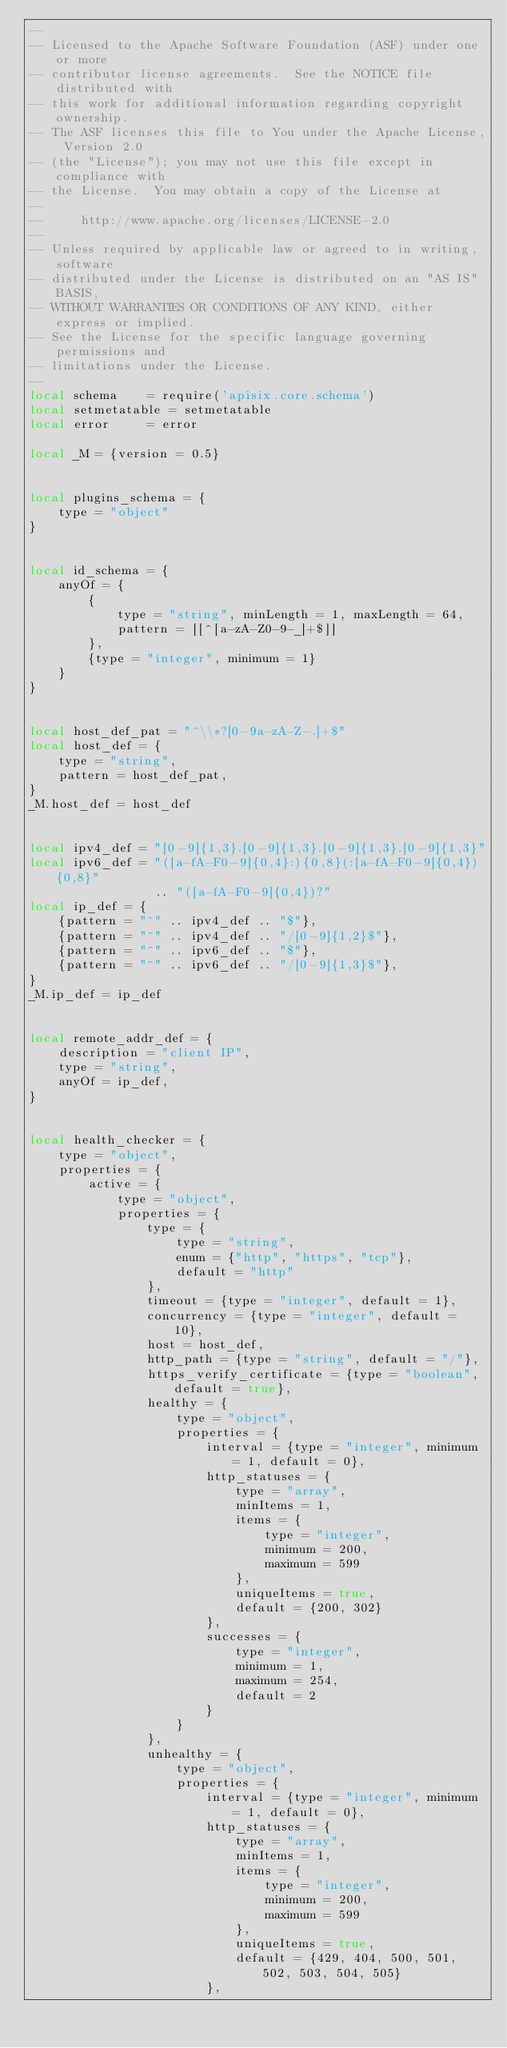<code> <loc_0><loc_0><loc_500><loc_500><_Lua_>--
-- Licensed to the Apache Software Foundation (ASF) under one or more
-- contributor license agreements.  See the NOTICE file distributed with
-- this work for additional information regarding copyright ownership.
-- The ASF licenses this file to You under the Apache License, Version 2.0
-- (the "License"); you may not use this file except in compliance with
-- the License.  You may obtain a copy of the License at
--
--     http://www.apache.org/licenses/LICENSE-2.0
--
-- Unless required by applicable law or agreed to in writing, software
-- distributed under the License is distributed on an "AS IS" BASIS,
-- WITHOUT WARRANTIES OR CONDITIONS OF ANY KIND, either express or implied.
-- See the License for the specific language governing permissions and
-- limitations under the License.
--
local schema    = require('apisix.core.schema')
local setmetatable = setmetatable
local error     = error

local _M = {version = 0.5}


local plugins_schema = {
    type = "object"
}


local id_schema = {
    anyOf = {
        {
            type = "string", minLength = 1, maxLength = 64,
            pattern = [[^[a-zA-Z0-9-_]+$]]
        },
        {type = "integer", minimum = 1}
    }
}


local host_def_pat = "^\\*?[0-9a-zA-Z-.]+$"
local host_def = {
    type = "string",
    pattern = host_def_pat,
}
_M.host_def = host_def


local ipv4_def = "[0-9]{1,3}.[0-9]{1,3}.[0-9]{1,3}.[0-9]{1,3}"
local ipv6_def = "([a-fA-F0-9]{0,4}:){0,8}(:[a-fA-F0-9]{0,4}){0,8}"
                 .. "([a-fA-F0-9]{0,4})?"
local ip_def = {
    {pattern = "^" .. ipv4_def .. "$"},
    {pattern = "^" .. ipv4_def .. "/[0-9]{1,2}$"},
    {pattern = "^" .. ipv6_def .. "$"},
    {pattern = "^" .. ipv6_def .. "/[0-9]{1,3}$"},
}
_M.ip_def = ip_def


local remote_addr_def = {
    description = "client IP",
    type = "string",
    anyOf = ip_def,
}


local health_checker = {
    type = "object",
    properties = {
        active = {
            type = "object",
            properties = {
                type = {
                    type = "string",
                    enum = {"http", "https", "tcp"},
                    default = "http"
                },
                timeout = {type = "integer", default = 1},
                concurrency = {type = "integer", default = 10},
                host = host_def,
                http_path = {type = "string", default = "/"},
                https_verify_certificate = {type = "boolean", default = true},
                healthy = {
                    type = "object",
                    properties = {
                        interval = {type = "integer", minimum = 1, default = 0},
                        http_statuses = {
                            type = "array",
                            minItems = 1,
                            items = {
                                type = "integer",
                                minimum = 200,
                                maximum = 599
                            },
                            uniqueItems = true,
                            default = {200, 302}
                        },
                        successes = {
                            type = "integer",
                            minimum = 1,
                            maximum = 254,
                            default = 2
                        }
                    }
                },
                unhealthy = {
                    type = "object",
                    properties = {
                        interval = {type = "integer", minimum = 1, default = 0},
                        http_statuses = {
                            type = "array",
                            minItems = 1,
                            items = {
                                type = "integer",
                                minimum = 200,
                                maximum = 599
                            },
                            uniqueItems = true,
                            default = {429, 404, 500, 501, 502, 503, 504, 505}
                        },</code> 